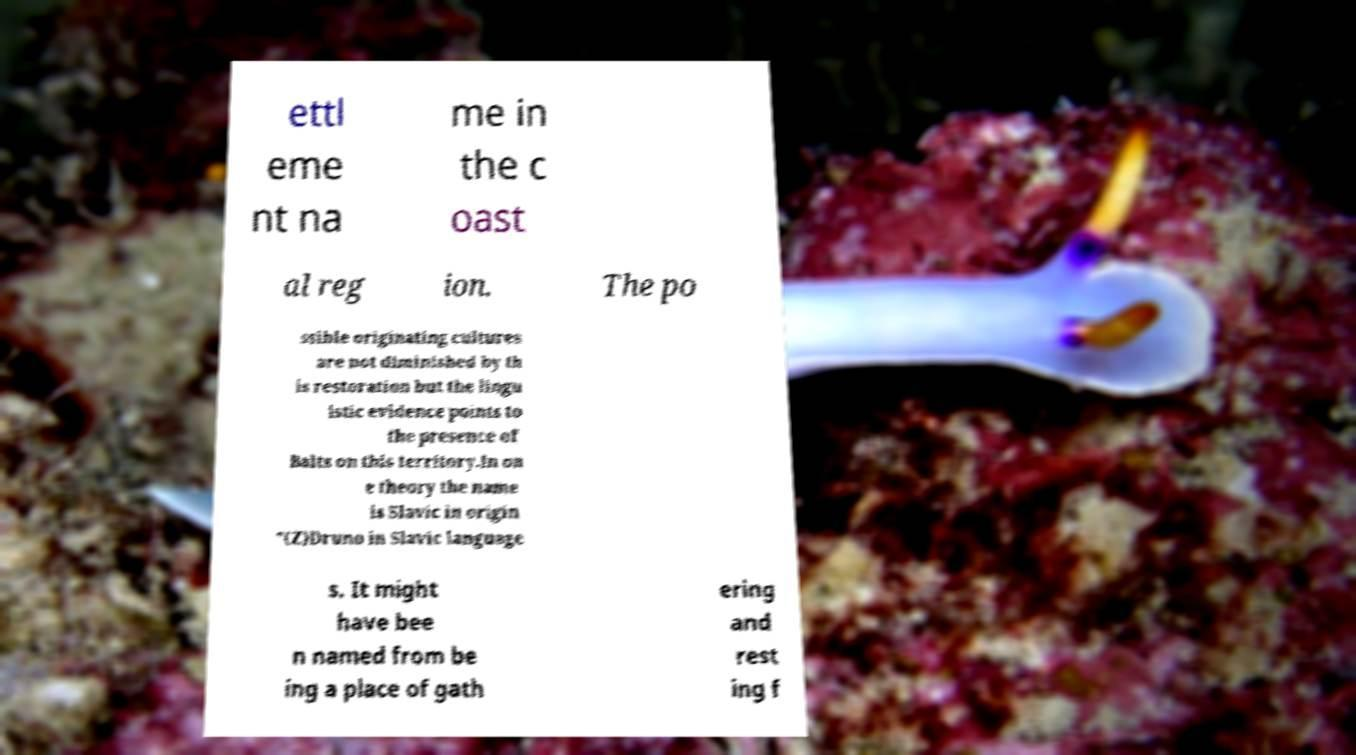Please identify and transcribe the text found in this image. ettl eme nt na me in the c oast al reg ion. The po ssible originating cultures are not diminished by th is restoration but the lingu istic evidence points to the presence of Balts on this territory.In on e theory the name is Slavic in origin "(Z)Druno in Slavic language s. It might have bee n named from be ing a place of gath ering and rest ing f 